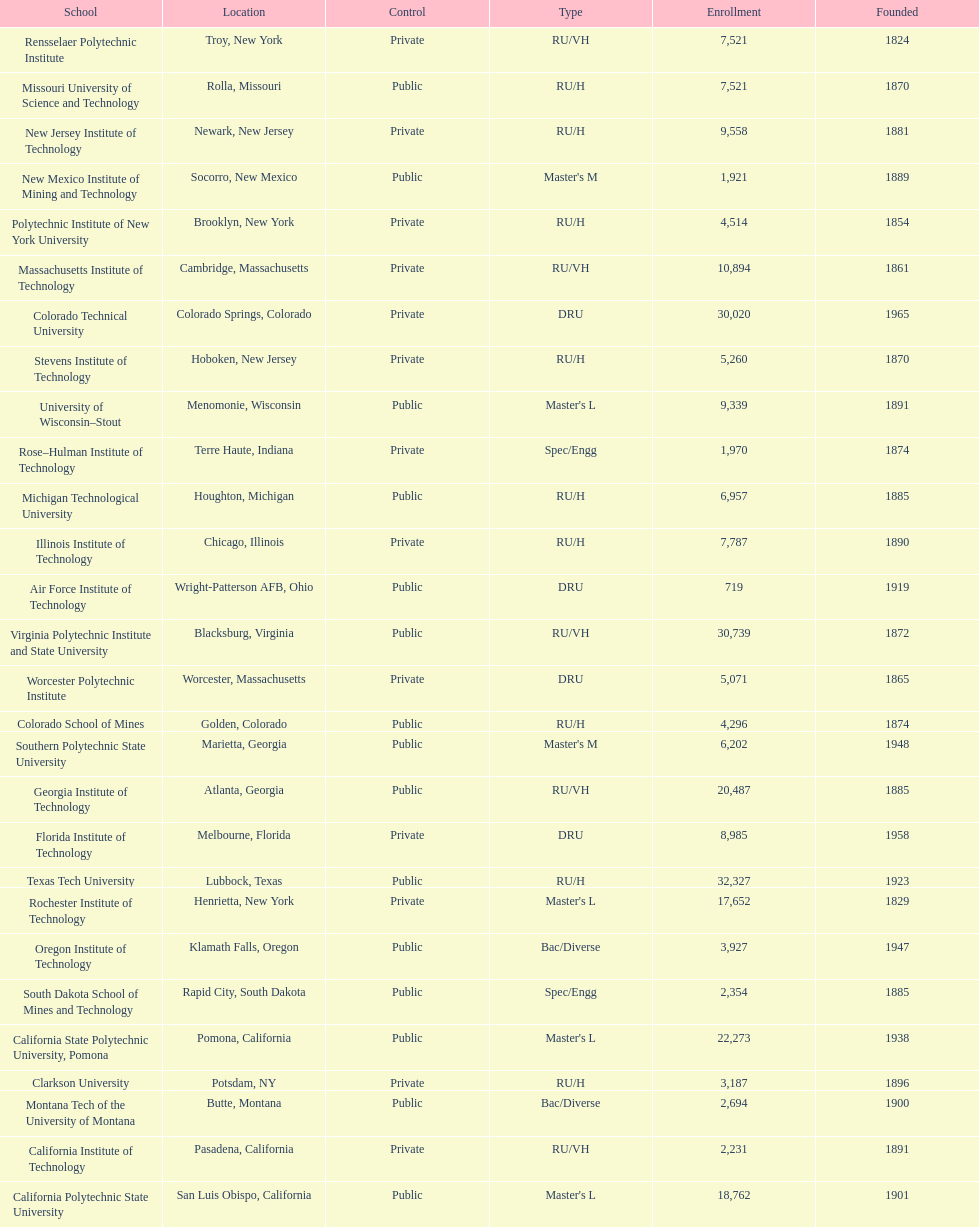What technical universities are in the united states? Air Force Institute of Technology, California Institute of Technology, California Polytechnic State University, California State Polytechnic University, Pomona, Clarkson University, Colorado School of Mines, Colorado Technical University, Florida Institute of Technology, Georgia Institute of Technology, Illinois Institute of Technology, Massachusetts Institute of Technology, Michigan Technological University, Missouri University of Science and Technology, Montana Tech of the University of Montana, New Jersey Institute of Technology, New Mexico Institute of Mining and Technology, Oregon Institute of Technology, Polytechnic Institute of New York University, Rensselaer Polytechnic Institute, Rochester Institute of Technology, Rose–Hulman Institute of Technology, South Dakota School of Mines and Technology, Southern Polytechnic State University, Stevens Institute of Technology, Texas Tech University, University of Wisconsin–Stout, Virginia Polytechnic Institute and State University, Worcester Polytechnic Institute. Which has the highest enrollment? Texas Tech University. 